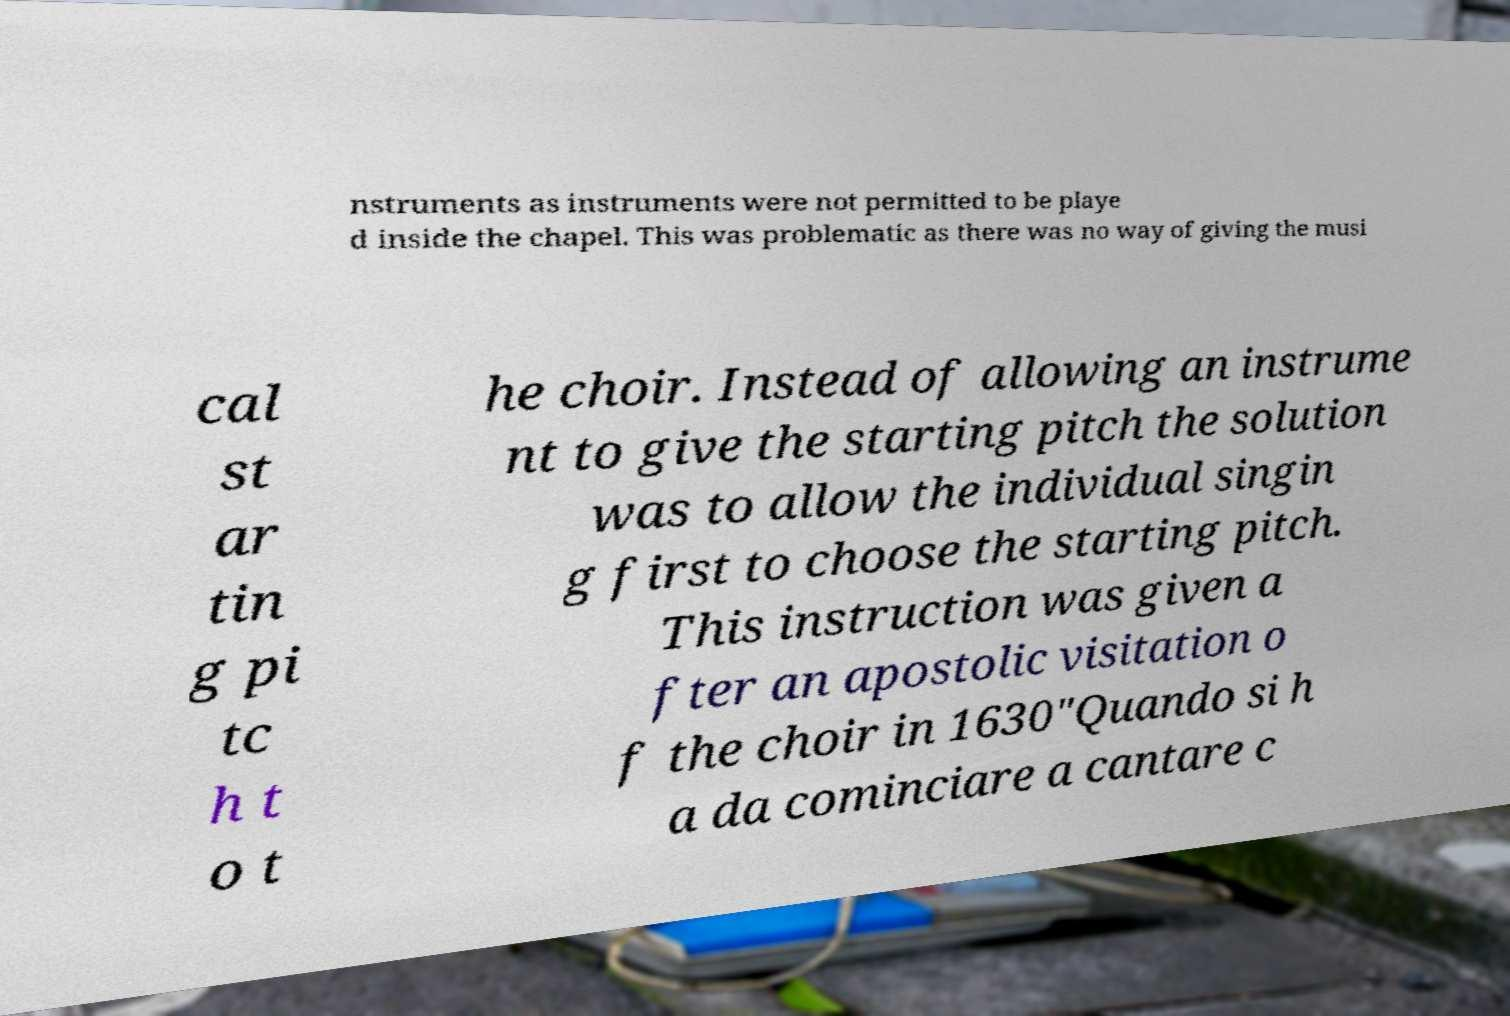I need the written content from this picture converted into text. Can you do that? nstruments as instruments were not permitted to be playe d inside the chapel. This was problematic as there was no way of giving the musi cal st ar tin g pi tc h t o t he choir. Instead of allowing an instrume nt to give the starting pitch the solution was to allow the individual singin g first to choose the starting pitch. This instruction was given a fter an apostolic visitation o f the choir in 1630"Quando si h a da cominciare a cantare c 